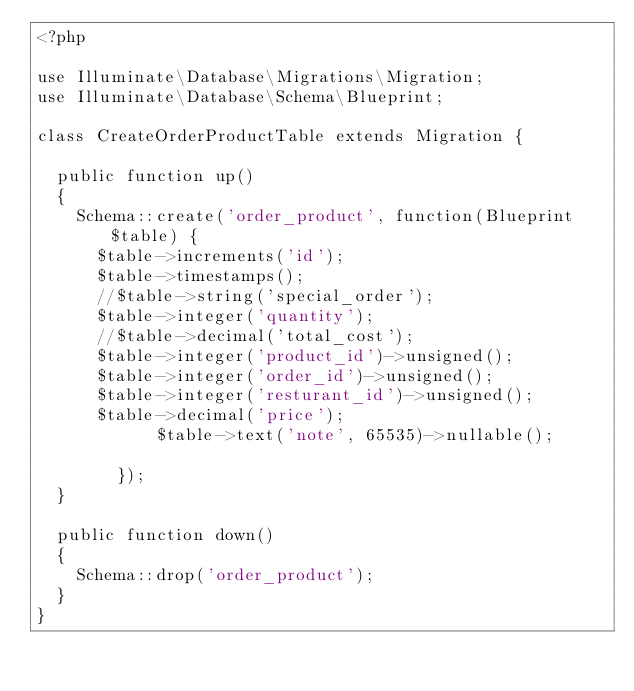<code> <loc_0><loc_0><loc_500><loc_500><_PHP_><?php

use Illuminate\Database\Migrations\Migration;
use Illuminate\Database\Schema\Blueprint;

class CreateOrderProductTable extends Migration {

	public function up()
	{
		Schema::create('order_product', function(Blueprint $table) {
			$table->increments('id');
			$table->timestamps();
			//$table->string('special_order');
			$table->integer('quantity');
			//$table->decimal('total_cost');
			$table->integer('product_id')->unsigned();
			$table->integer('order_id')->unsigned();
			$table->integer('resturant_id')->unsigned();
			$table->decimal('price');
            $table->text('note', 65535)->nullable();

        });
	}

	public function down()
	{
		Schema::drop('order_product');
	}
}
</code> 